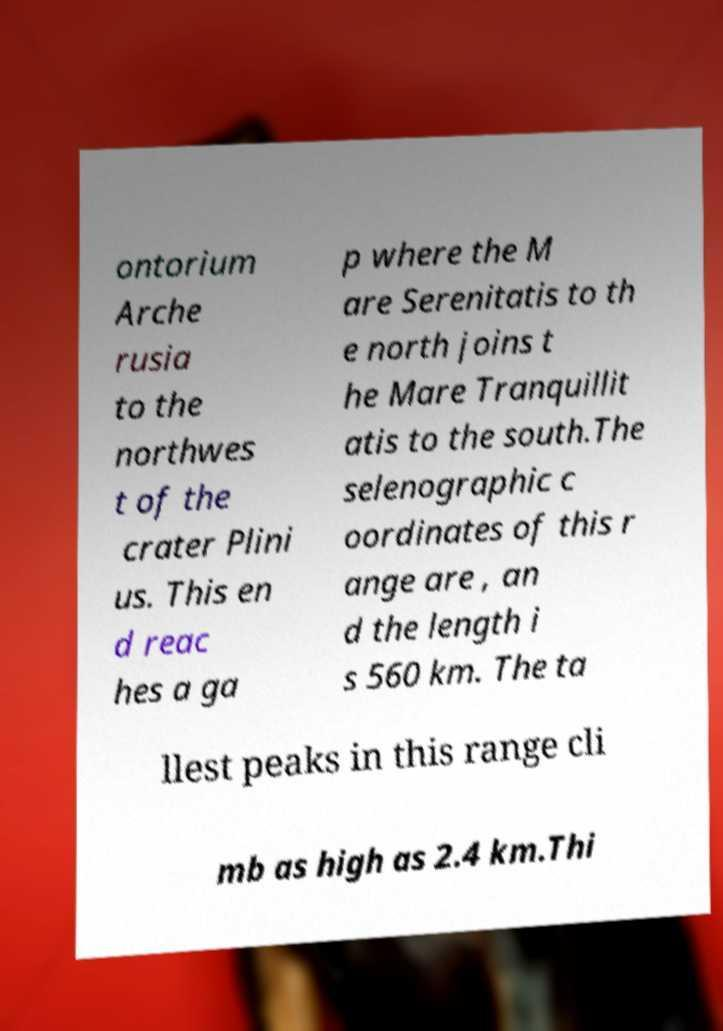Please read and relay the text visible in this image. What does it say? ontorium Arche rusia to the northwes t of the crater Plini us. This en d reac hes a ga p where the M are Serenitatis to th e north joins t he Mare Tranquillit atis to the south.The selenographic c oordinates of this r ange are , an d the length i s 560 km. The ta llest peaks in this range cli mb as high as 2.4 km.Thi 